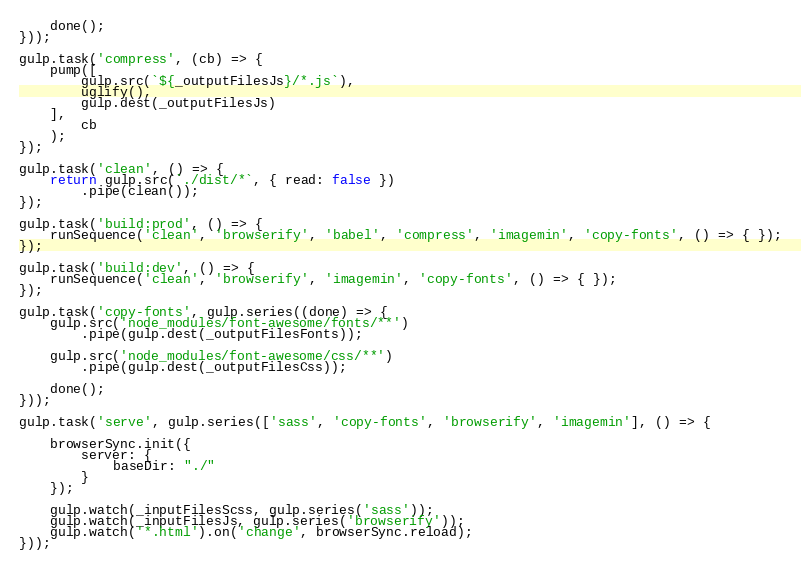Convert code to text. <code><loc_0><loc_0><loc_500><loc_500><_JavaScript_>    done();
}));

gulp.task('compress', (cb) => {
    pump([
        gulp.src(`${_outputFilesJs}/*.js`),
        uglify(),
        gulp.dest(_outputFilesJs)
    ],
        cb
    );
});

gulp.task('clean', () => {
    return gulp.src(`./dist/*`, { read: false })
        .pipe(clean());
});

gulp.task('build:prod', () => {
    runSequence('clean', 'browserify', 'babel', 'compress', 'imagemin', 'copy-fonts', () => { });
});

gulp.task('build:dev', () => {
    runSequence('clean', 'browserify', 'imagemin', 'copy-fonts', () => { });
});

gulp.task('copy-fonts', gulp.series((done) => {
    gulp.src('node_modules/font-awesome/fonts/**')
        .pipe(gulp.dest(_outputFilesFonts));

    gulp.src('node_modules/font-awesome/css/**')
        .pipe(gulp.dest(_outputFilesCss));

    done();
}));

gulp.task('serve', gulp.series(['sass', 'copy-fonts', 'browserify', 'imagemin'], () => {

    browserSync.init({
        server: {
            baseDir: "./"
        }
    });

    gulp.watch(_inputFilesScss, gulp.series('sass'));
    gulp.watch(_inputFilesJs, gulp.series('browserify'));
    gulp.watch('*.html').on('change', browserSync.reload);
}));
</code> 